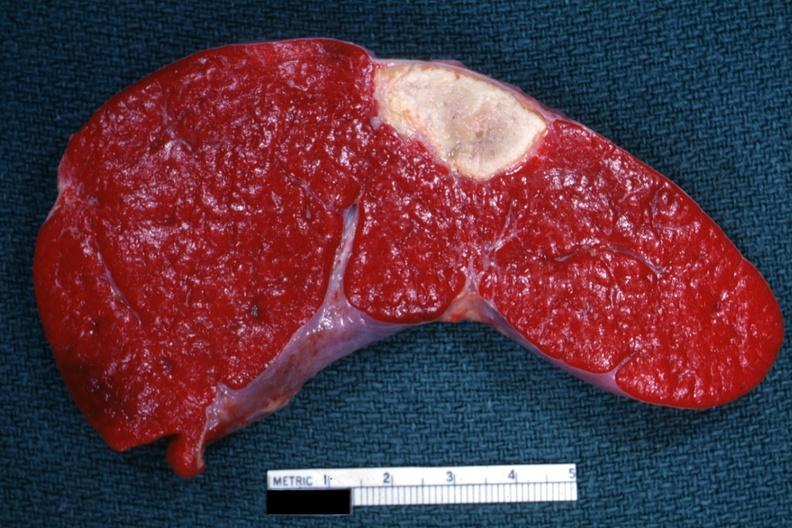s hematologic present?
Answer the question using a single word or phrase. Yes 